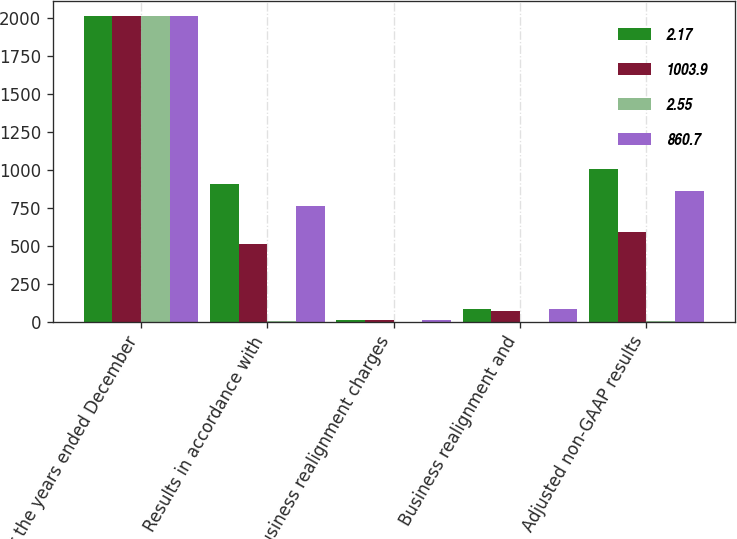Convert chart. <chart><loc_0><loc_0><loc_500><loc_500><stacked_bar_chart><ecel><fcel>For the years ended December<fcel>Results in accordance with<fcel>Business realignment charges<fcel>Business realignment and<fcel>Adjusted non-GAAP results<nl><fcel>2.17<fcel>2010<fcel>905.3<fcel>13.7<fcel>83.4<fcel>1003.9<nl><fcel>1003.9<fcel>2010<fcel>509.8<fcel>8.4<fcel>68.6<fcel>587.7<nl><fcel>2.55<fcel>2010<fcel>2.21<fcel>0.04<fcel>0.3<fcel>2.55<nl><fcel>860.7<fcel>2009<fcel>761.6<fcel>10.1<fcel>82.9<fcel>860.7<nl></chart> 